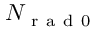<formula> <loc_0><loc_0><loc_500><loc_500>N _ { r a d 0 }</formula> 